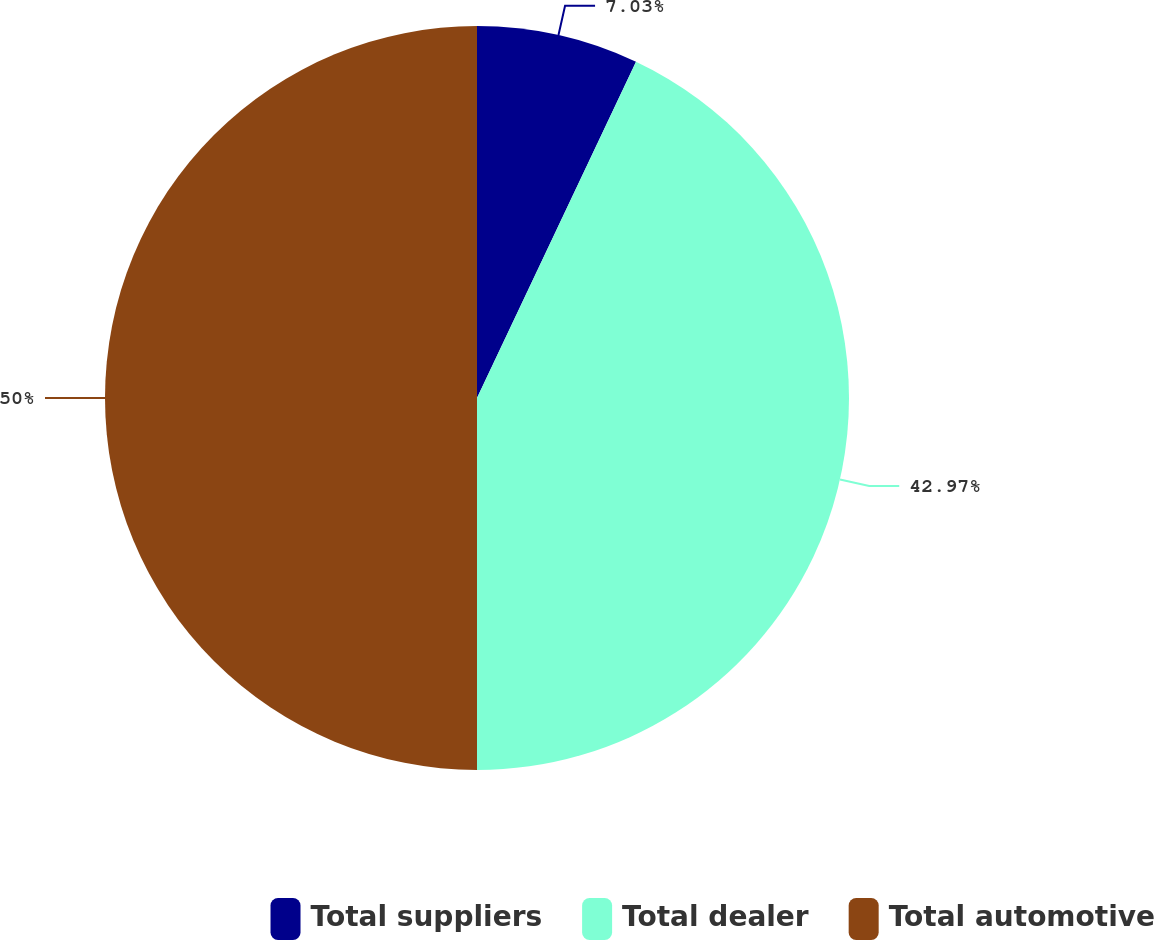Convert chart to OTSL. <chart><loc_0><loc_0><loc_500><loc_500><pie_chart><fcel>Total suppliers<fcel>Total dealer<fcel>Total automotive<nl><fcel>7.03%<fcel>42.97%<fcel>50.0%<nl></chart> 